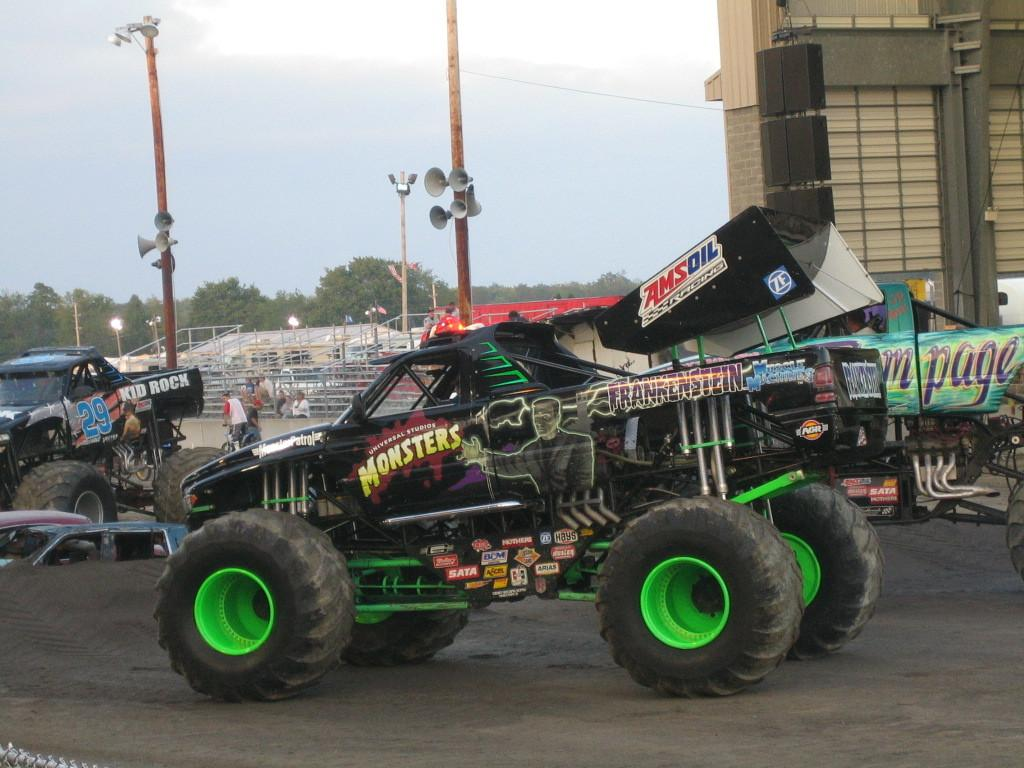What types of objects are present in the image? There are vehicles, a fence, buildings, lights, trees, and the sky is visible in the image. Can you describe the vehicles in the image? The provided facts do not specify the type of vehicles in the image. What is the fence made of in the image? The provided facts do not specify the material of the fence in the image. How many buildings can be seen in the image? The provided facts do not specify the number of buildings in the image. What is the color of the lights in the image? The provided facts do not specify the color of the lights in the image. How does the drain help the vehicles in the image? There is no mention of a drain in the provided facts, so it cannot be determined how a drain might help the vehicles in the image. What type of brass instrument is being played by the trees in the image? There is no brass instrument or any indication of music being played in the image, as the provided facts only mention trees and other objects. 